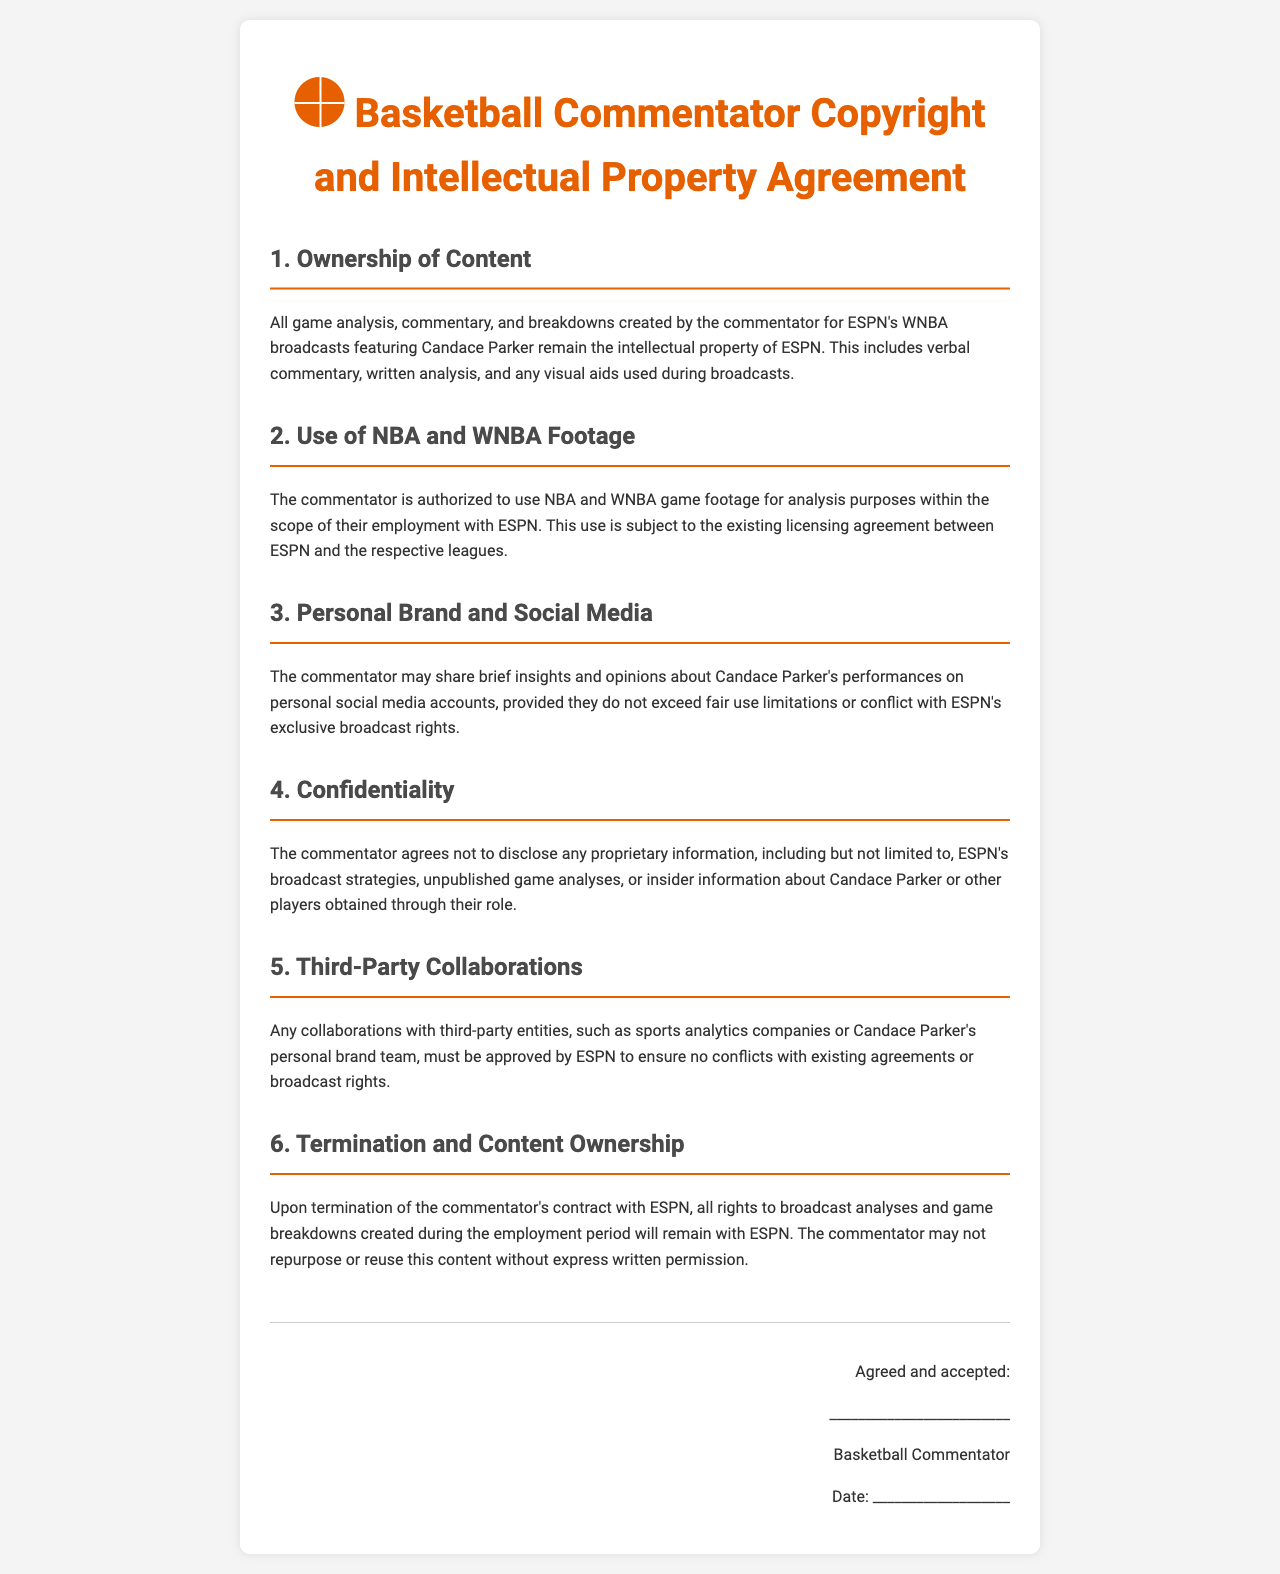What is the title of the document? The title is explicitly stated at the top of the document as "Basketball Commentator Copyright and Intellectual Property Agreement."
Answer: Basketball Commentator Copyright and Intellectual Property Agreement Who owns the content created by the commentator? The document specifies that all content created by the commentator remains the intellectual property of ESPN.
Answer: ESPN What type of footage is the commentator authorized to use? The document states that the commentator is authorized to use NBA and WNBA game footage for analysis purposes.
Answer: NBA and WNBA footage What must the commentator obtain before collaborating with third parties? The document mentions that any collaborations must be approved by ESPN to avoid conflicts with agreements.
Answer: Approval by ESPN What happens to the rights of content upon termination of the commentator's contract? It is stated that all rights to broadcast analyses remain with ESPN after the termination.
Answer: Remain with ESPN 